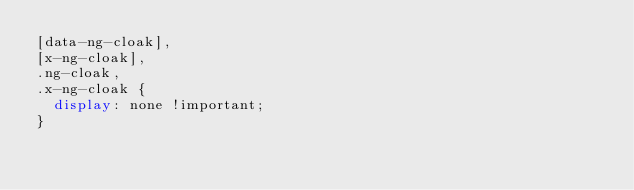<code> <loc_0><loc_0><loc_500><loc_500><_CSS_>[data-ng-cloak],
[x-ng-cloak],
.ng-cloak,
.x-ng-cloak {
  display: none !important;
}
</code> 